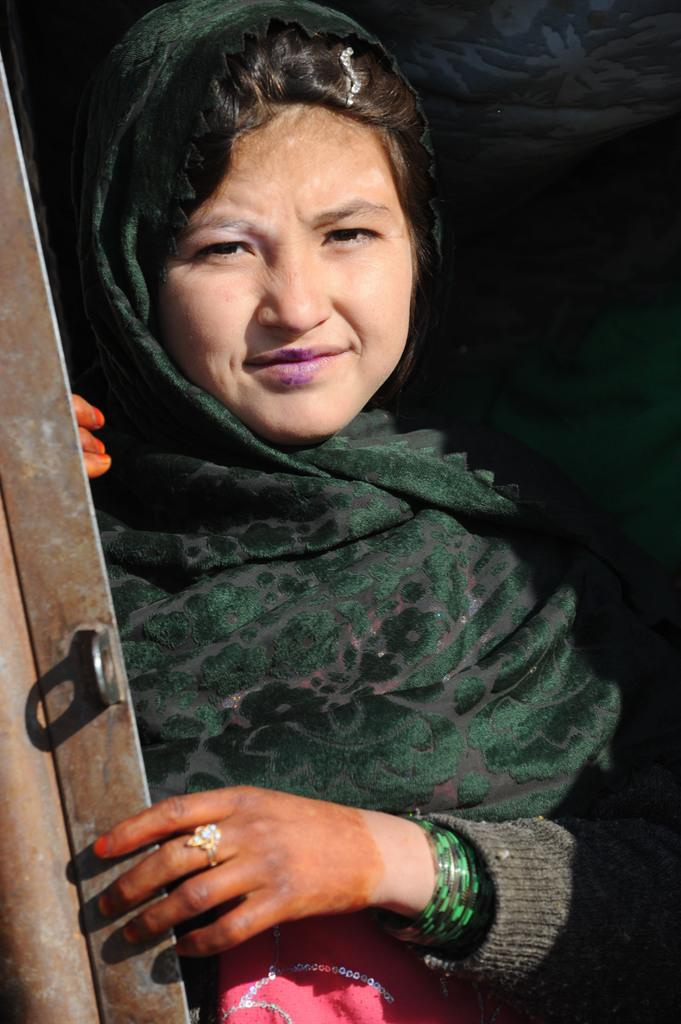Who is present in the image? There is a woman in the image. What is the woman's facial expression? The woman is smiling. What can be seen on the left side of the image? There is a metal object on the left side of the image. What type of process is being exchanged between the woman and the metal object in the image? There is no process or exchange between the woman and the metal object in the image; they are simply present in the same scene. 